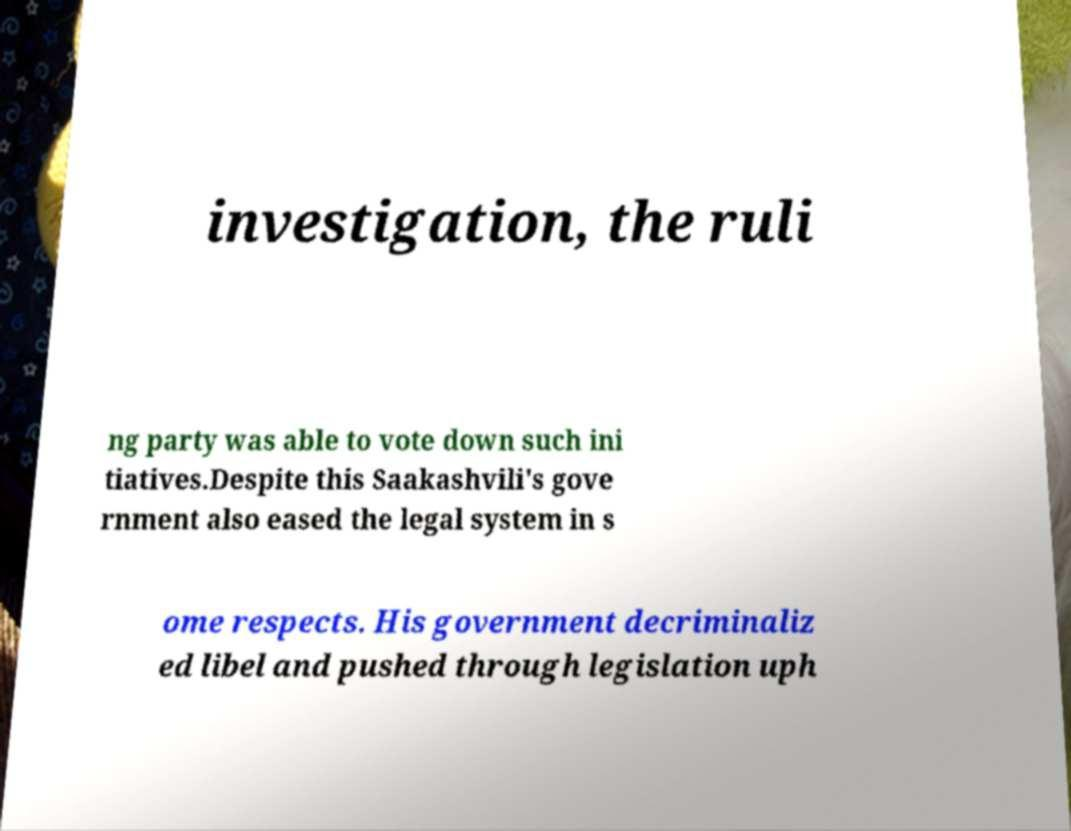What messages or text are displayed in this image? I need them in a readable, typed format. investigation, the ruli ng party was able to vote down such ini tiatives.Despite this Saakashvili's gove rnment also eased the legal system in s ome respects. His government decriminaliz ed libel and pushed through legislation uph 